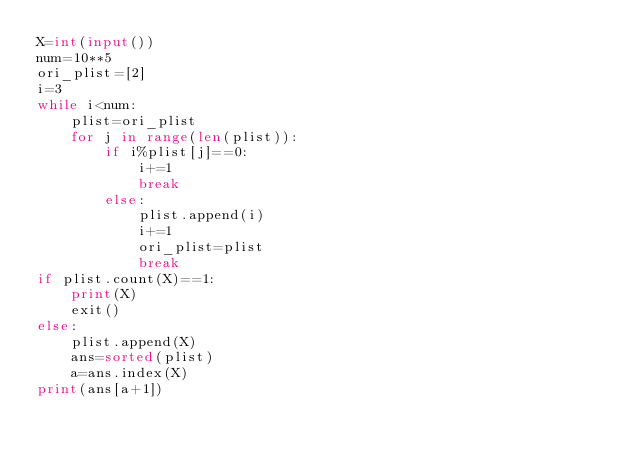Convert code to text. <code><loc_0><loc_0><loc_500><loc_500><_Python_>X=int(input())
num=10**5
ori_plist=[2]
i=3
while i<num:
    plist=ori_plist
    for j in range(len(plist)):
        if i%plist[j]==0:
            i+=1
            break
        else:
            plist.append(i)
            i+=1
            ori_plist=plist
            break
if plist.count(X)==1:
    print(X)
    exit()
else:
    plist.append(X)
    ans=sorted(plist)
    a=ans.index(X)
print(ans[a+1])</code> 